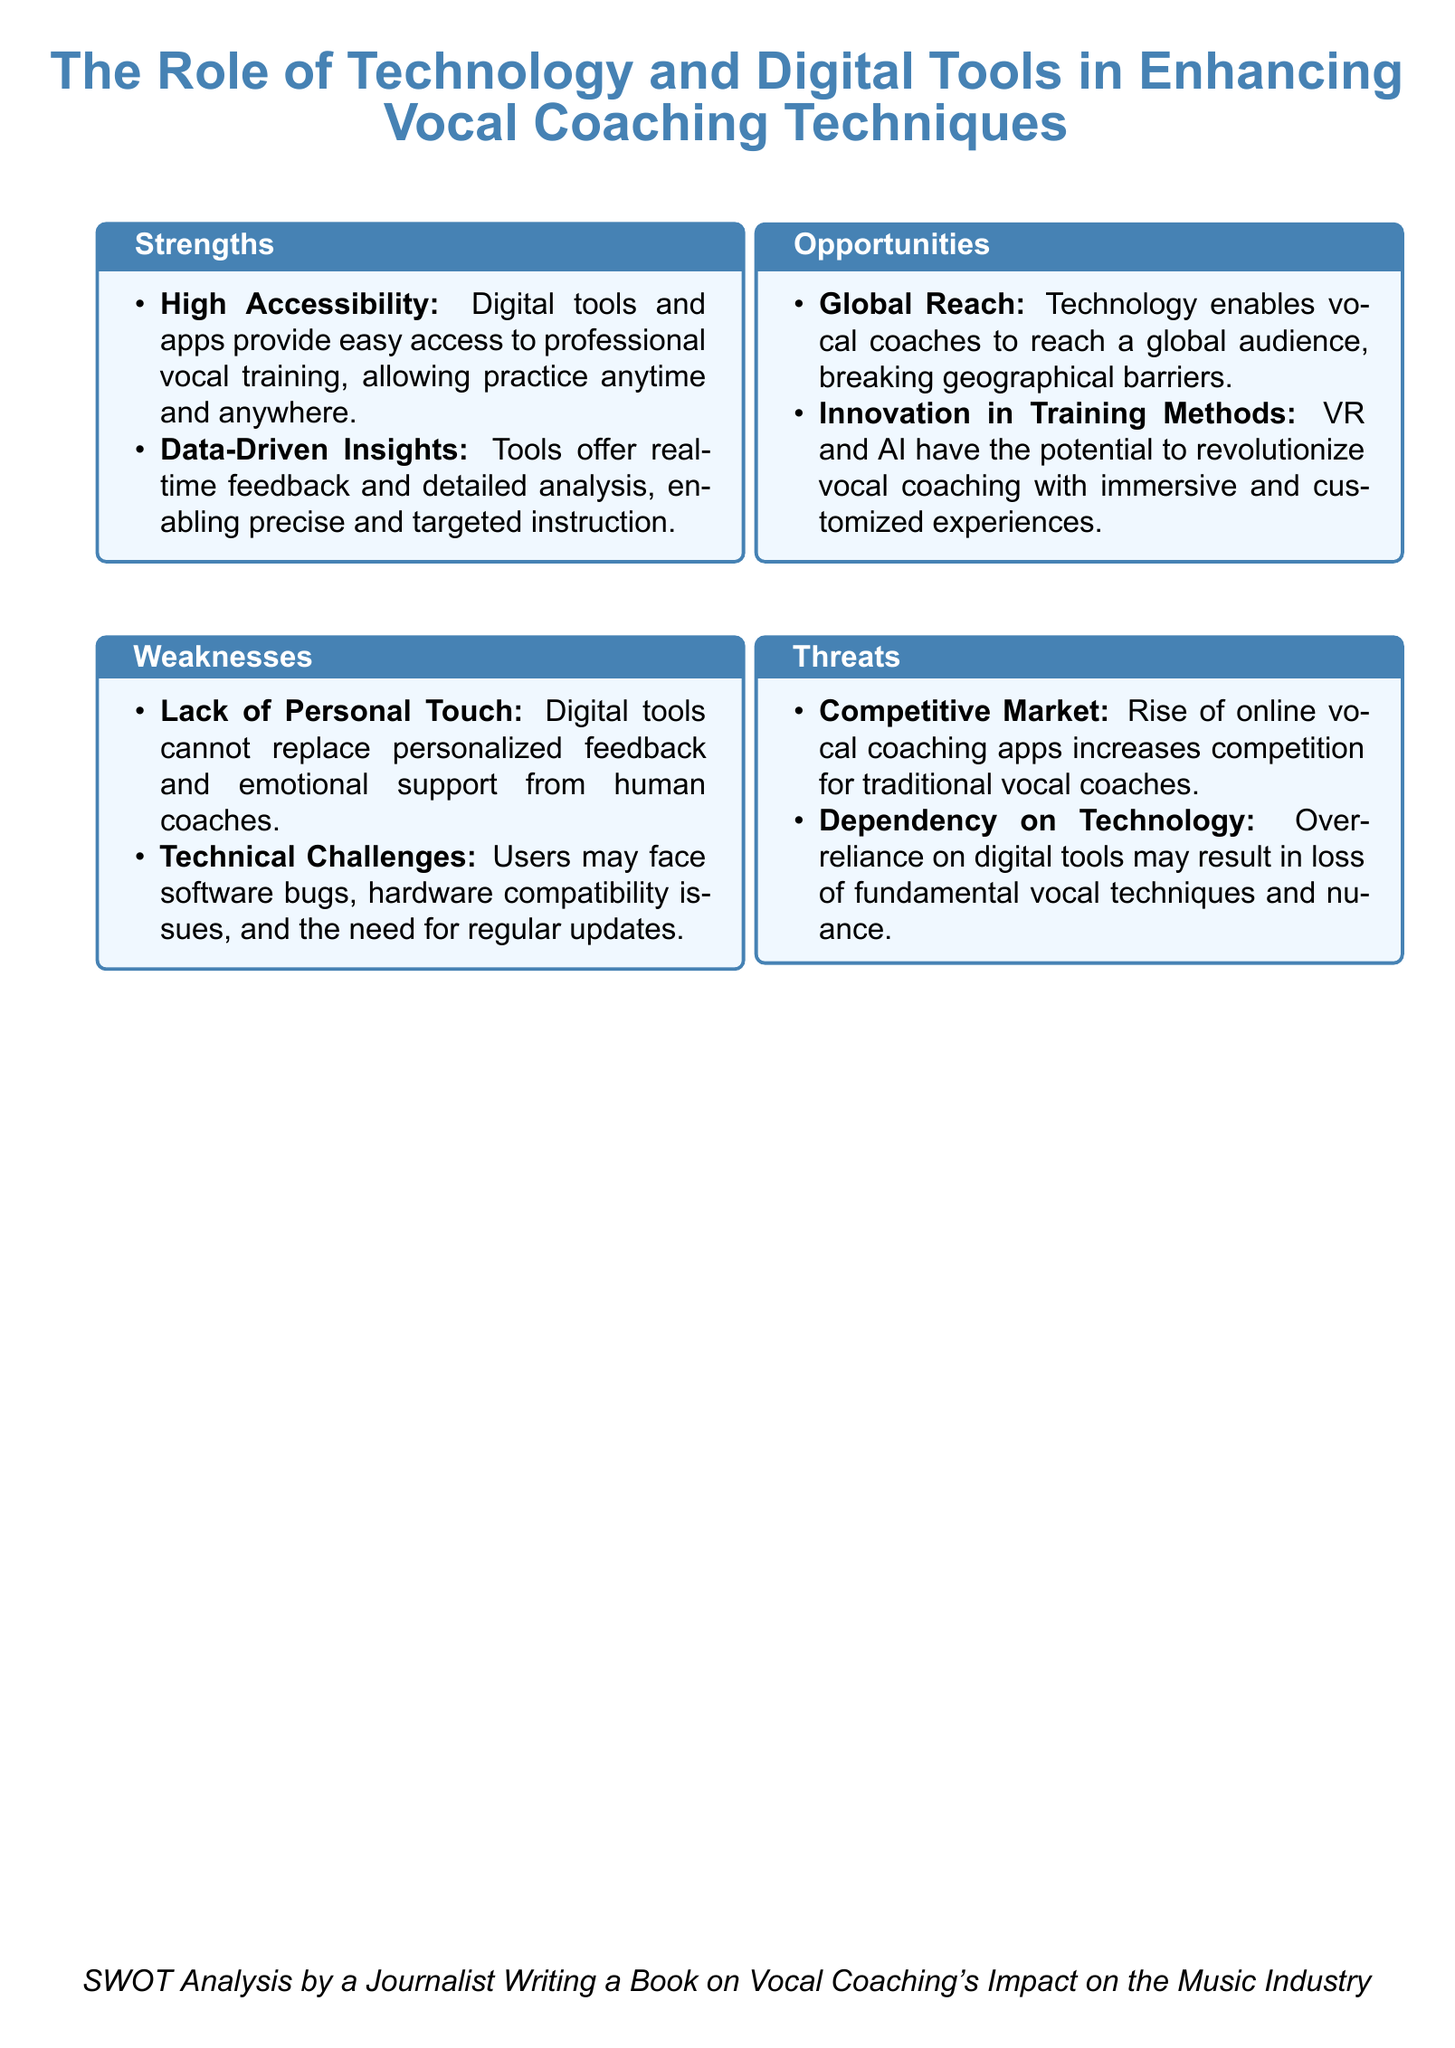What are the strengths mentioned in the document? The strengths are listed in the "Strengths" box of the SWOT analysis, which includes high accessibility and data-driven insights.
Answer: High Accessibility, Data-Driven Insights What is one of the weaknesses of digital tools in vocal coaching? The weaknesses are provided in the "Weaknesses" box, and one is the lack of personal touch in feedback.
Answer: Lack of Personal Touch Which technology is mentioned as having the potential to revolutionize vocal coaching? The "Opportunities" section mentions VR (Virtual Reality) and AI (Artificial Intelligence) as innovative training methods.
Answer: VR and AI What is the main threat to traditional vocal coaches? The threat related to competition is highlighted in the "Threats" box, specifically regarding online vocal coaching apps.
Answer: Competitive Market How do digital tools enhance vocal training according to the strengths? The strengths also mention that digital tools provide real-time feedback and detailed analysis for targeted instruction.
Answer: Real-time feedback, Detailed analysis What is identified as a potential opportunity for vocal coaches? The "Opportunities" section notes global reach as a significant advantage of technology in vocal coaching.
Answer: Global Reach What issue might users face with digital coaching tools? The weaknesses state that users may encounter technical challenges, which include software bugs and compatibility issues.
Answer: Technical Challenges What does the SWOT analysis aim to assess? The document assesses the role and impact of technology and digital tools on vocal coaching techniques via a SWOT analysis framework.
Answer: Role of Technology and Digital Tools 